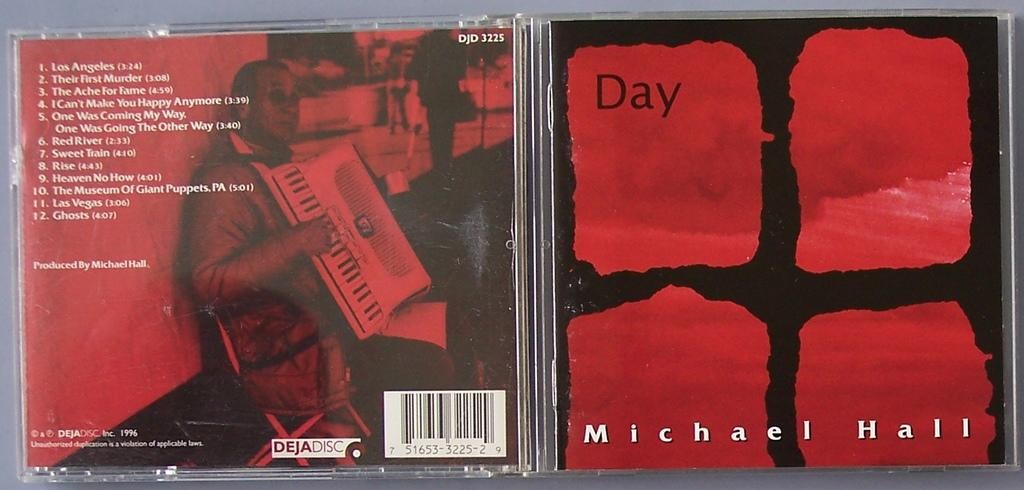What object is on the floor in the image? There is a disc cover on the floor in the image. What can be found on the disc cover? There is text on the disc cover. Who is present in the image? There is a person in the image. What is the person doing? The person is holding a musical instrument. Where is the person located in the image? The person is on the left side of the image. Can you see any afterthoughts in the image? There are no afterthoughts present in the image. What type of bottle is being used by the person in the image? There is no bottle visible in the image; the person is holding a musical instrument. 